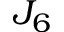<formula> <loc_0><loc_0><loc_500><loc_500>J _ { 6 }</formula> 